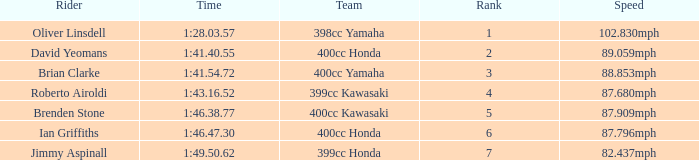What is the rank of the rider with time of 1:41.40.55? 2.0. 